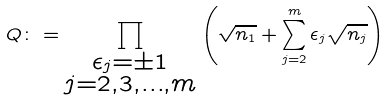<formula> <loc_0><loc_0><loc_500><loc_500>Q \colon = \prod _ { \substack { \epsilon _ { j } = \pm 1 \\ j = 2 , 3 , \dots , m } } \left ( \sqrt { n _ { 1 } } + \sum _ { j = 2 } ^ { m } \epsilon _ { j } \sqrt { n _ { j } } \right )</formula> 